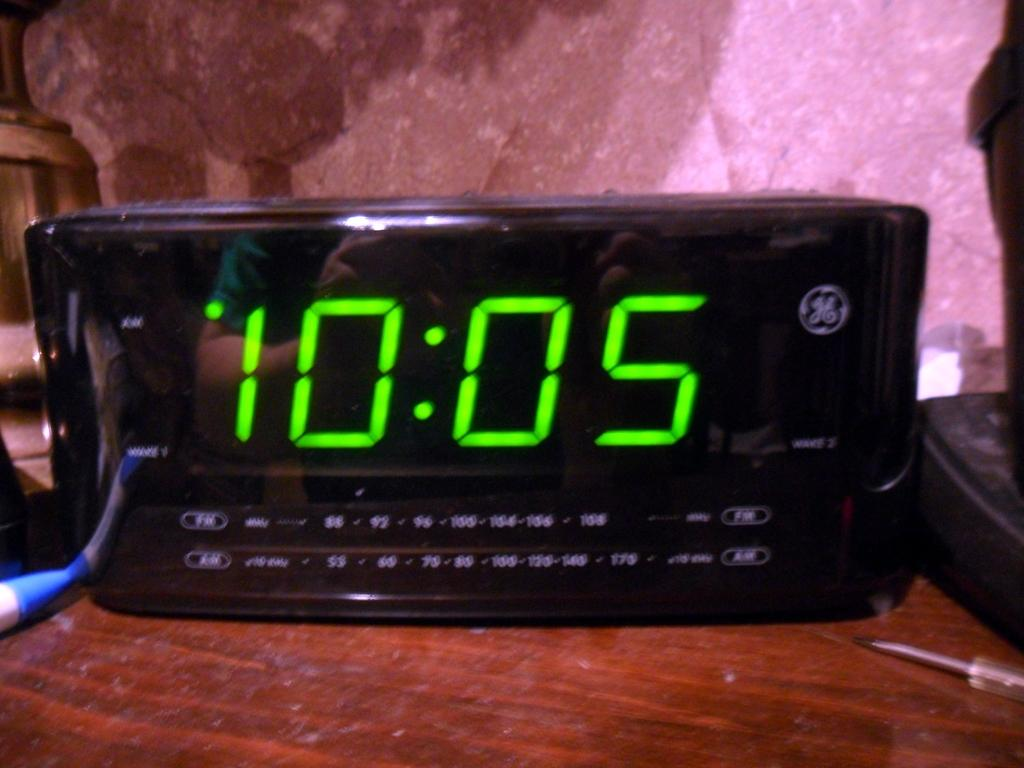<image>
Describe the image concisely. a GE clock with big green letters reading 10:05 